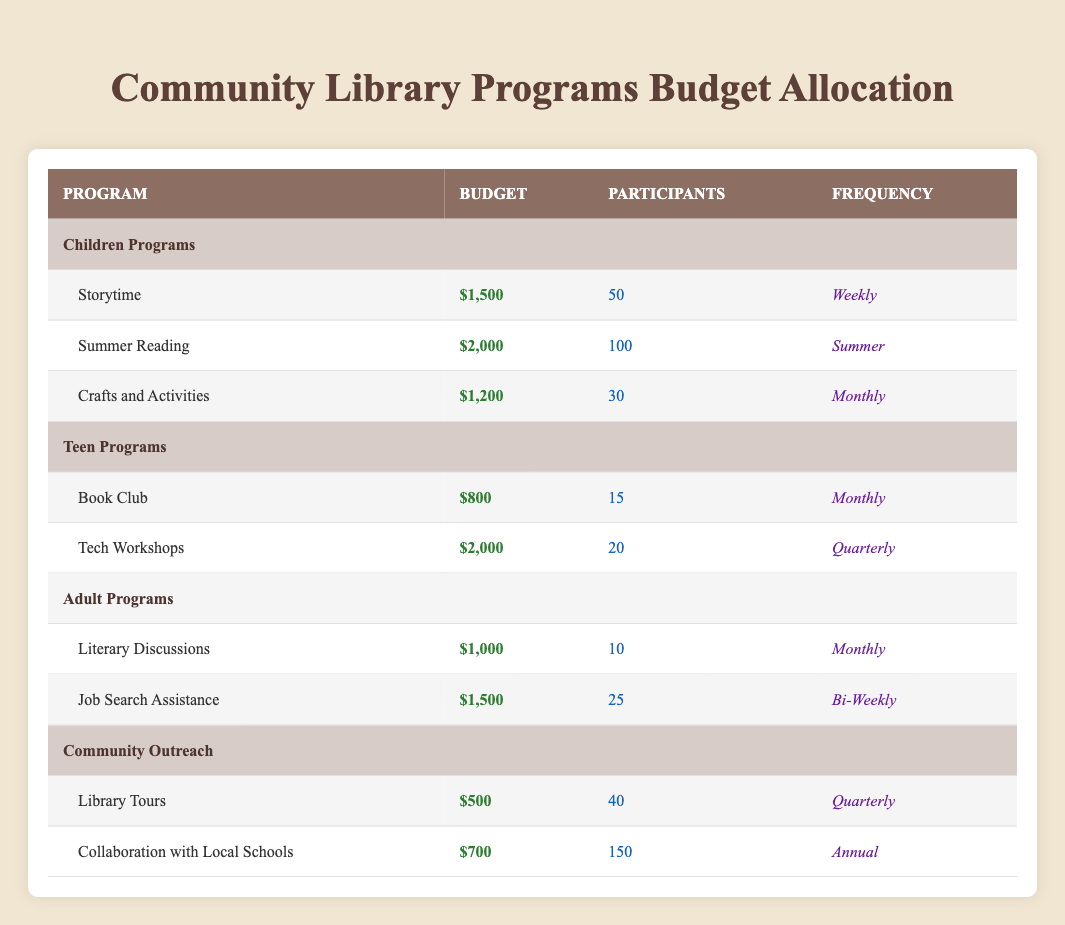What is the budget for the Summer Reading program? The budget for the Summer Reading program is listed directly in the table under the Children Programs section. It states that the budget is $2,000.
Answer: $2,000 How many participants are involved in Crafts and Activities? The table specifies the number of participants involved in Crafts and Activities under the Children Programs section. It shows that there are 30 participants.
Answer: 30 What is the total budget allocated for Adult Programs? To find the total budget for Adult Programs, I sum the budgets of Literary Discussions ($1,000) and Job Search Assistance ($1,500). The total budget is $1,000 + $1,500 = $2,500.
Answer: $2,500 Is the frequency of the Book Club program monthly? The table indicates the frequency of the Book Club program under the Teen Programs section. It states that its frequency is indeed monthly, making this statement true.
Answer: Yes How many total participants are there in Children Programs? To find the total for Children Programs, I check the participants in each program: Storytime (50), Summer Reading (100), and Crafts and Activities (30). Adding them gives: 50 + 100 + 30 = 180 participants total.
Answer: 180 What program has the highest budget among the listed programs? I need to compare the budgets of all programs. The highest is Summer Reading at $2,000. Other notable budgets include Tech Workshops and Job Search Assistance at $2,000 and $1,500 respectively, but Summer Reading stands out as the maximum.
Answer: Summer Reading Is there a program in the Community Outreach with a budget over $600? Reviewing both programs in Community Outreach, Library Tours has a budget of $500 and Collaboration with Local Schools has a budget of $700. Since $700 exceeds $600, the statement is true.
Answer: Yes What is the average budget of the Teen Programs? To find the average budget, I first sum the budgets of both Teen Programs: Book Club ($800) and Tech Workshops ($2,000), giving a total of $800 + $2,000 = $2,800. There are 2 programs, thus the average budget is $2,800 / 2 = $1,400.
Answer: $1,400 What is the total number of participants for all programs combined? I must add the participants from all categories: Children Programs (50 + 100 + 30 = 180), Teen Programs (15 + 20 = 35), Adult Programs (10 + 25 = 35), and Community Outreach (40 + 150 = 190). Summing these totals gives 180 + 35 + 35 + 190 = 440 total participants.
Answer: 440 